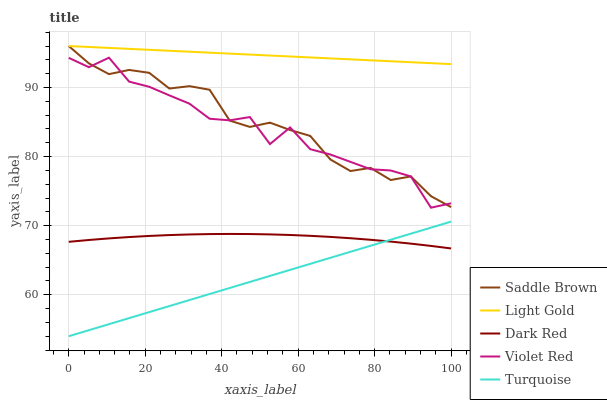Does Turquoise have the minimum area under the curve?
Answer yes or no. Yes. Does Light Gold have the maximum area under the curve?
Answer yes or no. Yes. Does Violet Red have the minimum area under the curve?
Answer yes or no. No. Does Violet Red have the maximum area under the curve?
Answer yes or no. No. Is Turquoise the smoothest?
Answer yes or no. Yes. Is Violet Red the roughest?
Answer yes or no. Yes. Is Violet Red the smoothest?
Answer yes or no. No. Is Turquoise the roughest?
Answer yes or no. No. Does Turquoise have the lowest value?
Answer yes or no. Yes. Does Violet Red have the lowest value?
Answer yes or no. No. Does Saddle Brown have the highest value?
Answer yes or no. Yes. Does Violet Red have the highest value?
Answer yes or no. No. Is Dark Red less than Saddle Brown?
Answer yes or no. Yes. Is Saddle Brown greater than Dark Red?
Answer yes or no. Yes. Does Dark Red intersect Turquoise?
Answer yes or no. Yes. Is Dark Red less than Turquoise?
Answer yes or no. No. Is Dark Red greater than Turquoise?
Answer yes or no. No. Does Dark Red intersect Saddle Brown?
Answer yes or no. No. 